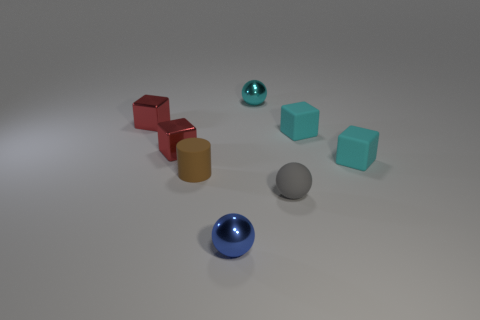Is there any other thing that is the same size as the brown cylinder?
Offer a very short reply. Yes. Do the tiny sphere that is on the right side of the cyan metallic sphere and the small cylinder have the same material?
Your answer should be compact. Yes. The tiny blue shiny object is what shape?
Your response must be concise. Sphere. How many cyan objects are tiny matte blocks or metallic blocks?
Provide a short and direct response. 2. Do the matte thing left of the small cyan shiny ball and the tiny blue metal object have the same shape?
Your answer should be very brief. No. Is there a tiny brown rubber thing?
Your response must be concise. Yes. Are there any other things that are the same shape as the tiny blue object?
Your response must be concise. Yes. Are there more brown objects behind the small cyan metal sphere than tiny metallic balls?
Your response must be concise. No. There is a blue object; are there any small things in front of it?
Ensure brevity in your answer.  No. Do the blue metallic object and the brown thing have the same size?
Offer a terse response. Yes. 